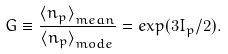Convert formula to latex. <formula><loc_0><loc_0><loc_500><loc_500>G \equiv \frac { { \langle n _ { p } \rangle } _ { m e a n } } { { \langle n _ { p } \rangle } _ { m o d e } } = e x p ( 3 I _ { p } / 2 ) .</formula> 